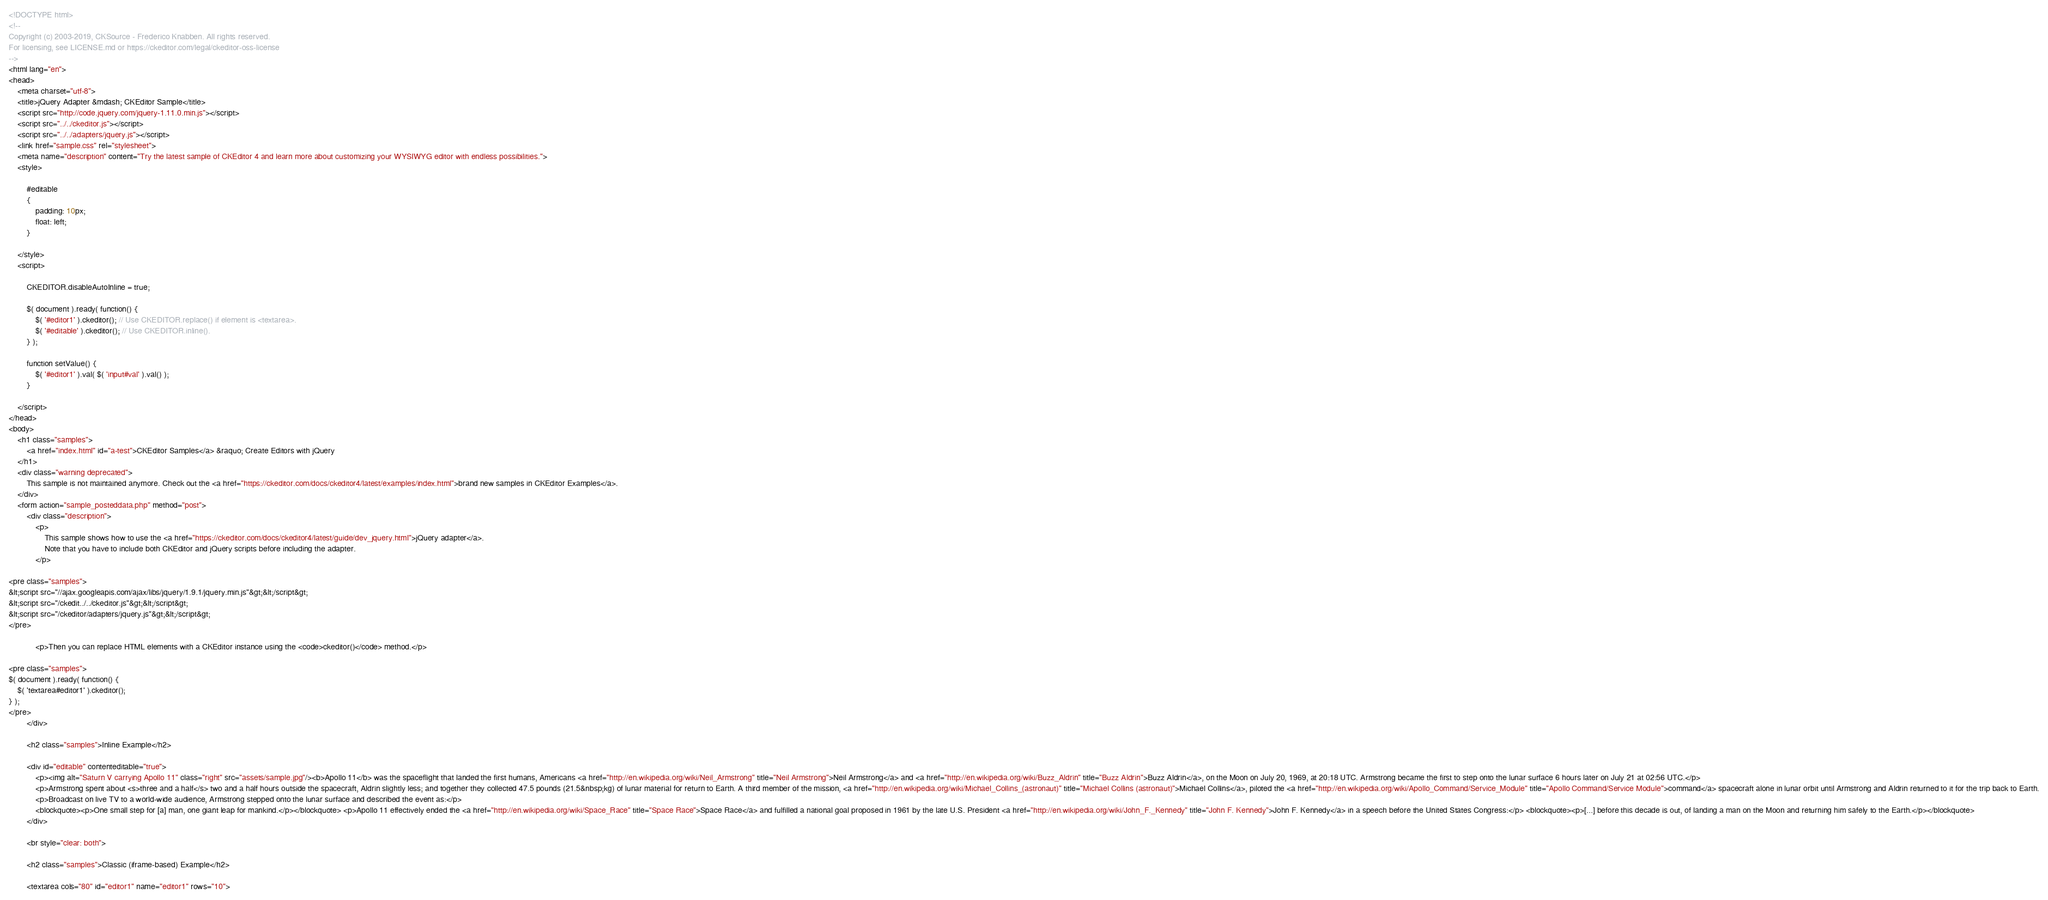<code> <loc_0><loc_0><loc_500><loc_500><_HTML_><!DOCTYPE html>
<!--
Copyright (c) 2003-2019, CKSource - Frederico Knabben. All rights reserved.
For licensing, see LICENSE.md or https://ckeditor.com/legal/ckeditor-oss-license
-->
<html lang="en">
<head>
	<meta charset="utf-8">
	<title>jQuery Adapter &mdash; CKEditor Sample</title>
	<script src="http://code.jquery.com/jquery-1.11.0.min.js"></script>
	<script src="../../ckeditor.js"></script>
	<script src="../../adapters/jquery.js"></script>
	<link href="sample.css" rel="stylesheet">
	<meta name="description" content="Try the latest sample of CKEditor 4 and learn more about customizing your WYSIWYG editor with endless possibilities.">
	<style>

		#editable
		{
			padding: 10px;
			float: left;
		}

	</style>
	<script>

		CKEDITOR.disableAutoInline = true;

		$( document ).ready( function() {
			$( '#editor1' ).ckeditor(); // Use CKEDITOR.replace() if element is <textarea>.
			$( '#editable' ).ckeditor(); // Use CKEDITOR.inline().
		} );

		function setValue() {
			$( '#editor1' ).val( $( 'input#val' ).val() );
		}

	</script>
</head>
<body>
	<h1 class="samples">
		<a href="index.html" id="a-test">CKEditor Samples</a> &raquo; Create Editors with jQuery
	</h1>
	<div class="warning deprecated">
		This sample is not maintained anymore. Check out the <a href="https://ckeditor.com/docs/ckeditor4/latest/examples/index.html">brand new samples in CKEditor Examples</a>.
	</div>
	<form action="sample_posteddata.php" method="post">
		<div class="description">
			<p>
				This sample shows how to use the <a href="https://ckeditor.com/docs/ckeditor4/latest/guide/dev_jquery.html">jQuery adapter</a>.
				Note that you have to include both CKEditor and jQuery scripts before including the adapter.
			</p>

<pre class="samples">
&lt;script src="//ajax.googleapis.com/ajax/libs/jquery/1.9.1/jquery.min.js"&gt;&lt;/script&gt;
&lt;script src="/ckedit../../ckeditor.js"&gt;&lt;/script&gt;
&lt;script src="/ckeditor/adapters/jquery.js"&gt;&lt;/script&gt;
</pre>

			<p>Then you can replace HTML elements with a CKEditor instance using the <code>ckeditor()</code> method.</p>

<pre class="samples">
$( document ).ready( function() {
	$( 'textarea#editor1' ).ckeditor();
} );
</pre>
		</div>

		<h2 class="samples">Inline Example</h2>

		<div id="editable" contenteditable="true">
			<p><img alt="Saturn V carrying Apollo 11" class="right" src="assets/sample.jpg"/><b>Apollo 11</b> was the spaceflight that landed the first humans, Americans <a href="http://en.wikipedia.org/wiki/Neil_Armstrong" title="Neil Armstrong">Neil Armstrong</a> and <a href="http://en.wikipedia.org/wiki/Buzz_Aldrin" title="Buzz Aldrin">Buzz Aldrin</a>, on the Moon on July 20, 1969, at 20:18 UTC. Armstrong became the first to step onto the lunar surface 6 hours later on July 21 at 02:56 UTC.</p>
			<p>Armstrong spent about <s>three and a half</s> two and a half hours outside the spacecraft, Aldrin slightly less; and together they collected 47.5 pounds (21.5&nbsp;kg) of lunar material for return to Earth. A third member of the mission, <a href="http://en.wikipedia.org/wiki/Michael_Collins_(astronaut)" title="Michael Collins (astronaut)">Michael Collins</a>, piloted the <a href="http://en.wikipedia.org/wiki/Apollo_Command/Service_Module" title="Apollo Command/Service Module">command</a> spacecraft alone in lunar orbit until Armstrong and Aldrin returned to it for the trip back to Earth.
			<p>Broadcast on live TV to a world-wide audience, Armstrong stepped onto the lunar surface and described the event as:</p>
			<blockquote><p>One small step for [a] man, one giant leap for mankind.</p></blockquote> <p>Apollo 11 effectively ended the <a href="http://en.wikipedia.org/wiki/Space_Race" title="Space Race">Space Race</a> and fulfilled a national goal proposed in 1961 by the late U.S. President <a href="http://en.wikipedia.org/wiki/John_F._Kennedy" title="John F. Kennedy">John F. Kennedy</a> in a speech before the United States Congress:</p> <blockquote><p>[...] before this decade is out, of landing a man on the Moon and returning him safely to the Earth.</p></blockquote>
		</div>

		<br style="clear: both">

		<h2 class="samples">Classic (iframe-based) Example</h2>

		<textarea cols="80" id="editor1" name="editor1" rows="10"></code> 